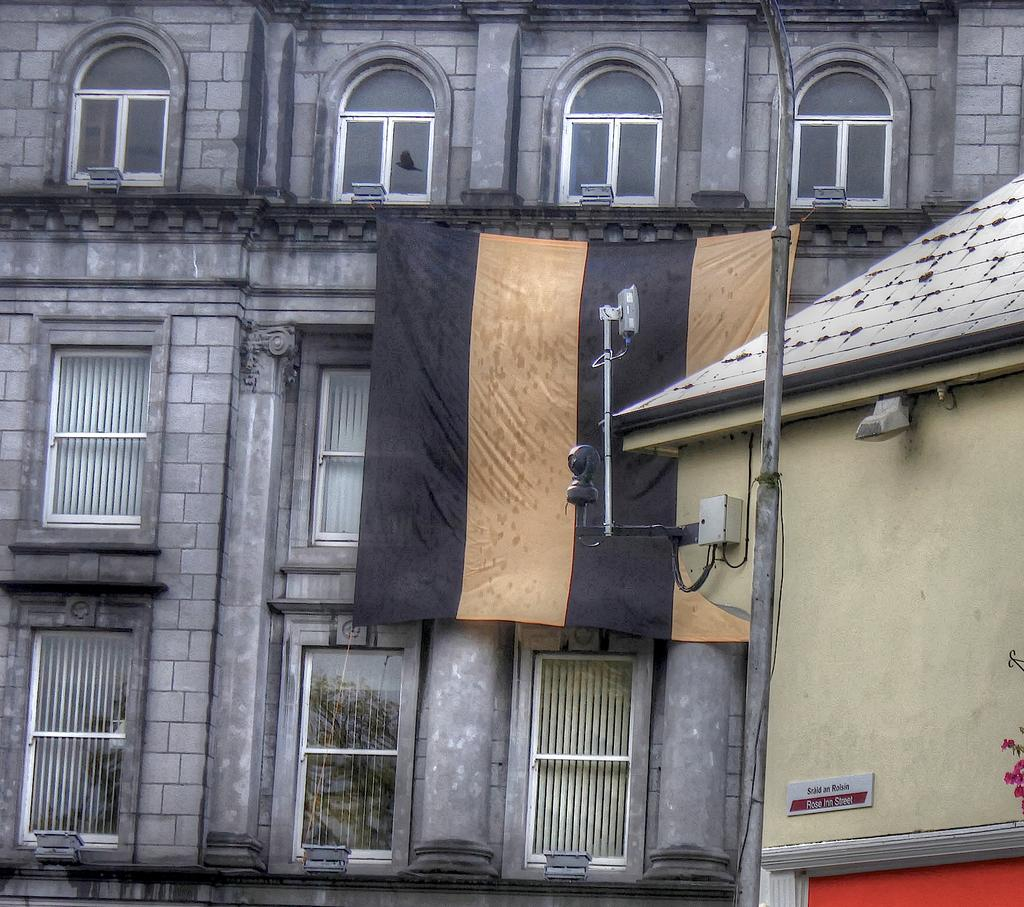What is located in the center of the image? There are buildings, windows, a cloth, lights, and a pole in the center of the image. Can you describe the windows in the image? The windows are part of the buildings in the center of the image. What is the purpose of the cloth in the image? The purpose of the cloth in the image is not specified, but it is located in the center of the image. What type of illumination is present in the image? There are lights in the center of the image. What is the pole used for in the image? The purpose of the pole in the image is not specified, but it is located in the center of the image. What type of veil is draped over the governor in the image? There is no veil or governor present in the image. How does the brother interact with the buildings in the image? There is no brother present in the image, and therefore no interaction with the buildings can be observed. 